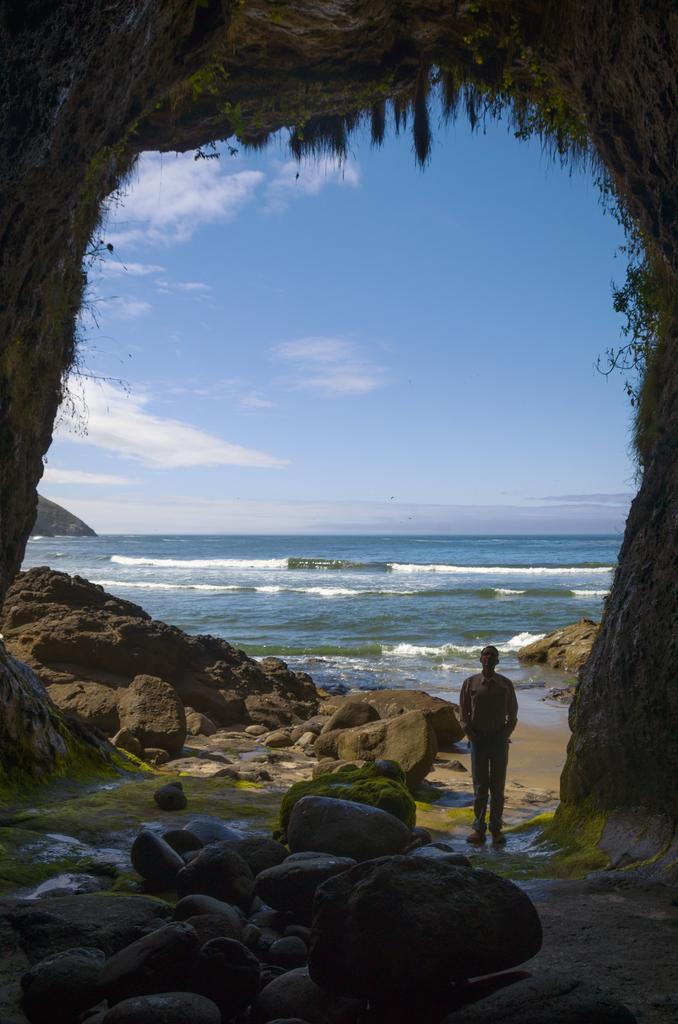Could you give a brief overview of what you see in this image? In this picture there is a person standing in the right corner and there are few rocks in front of him and there is water in the background. 